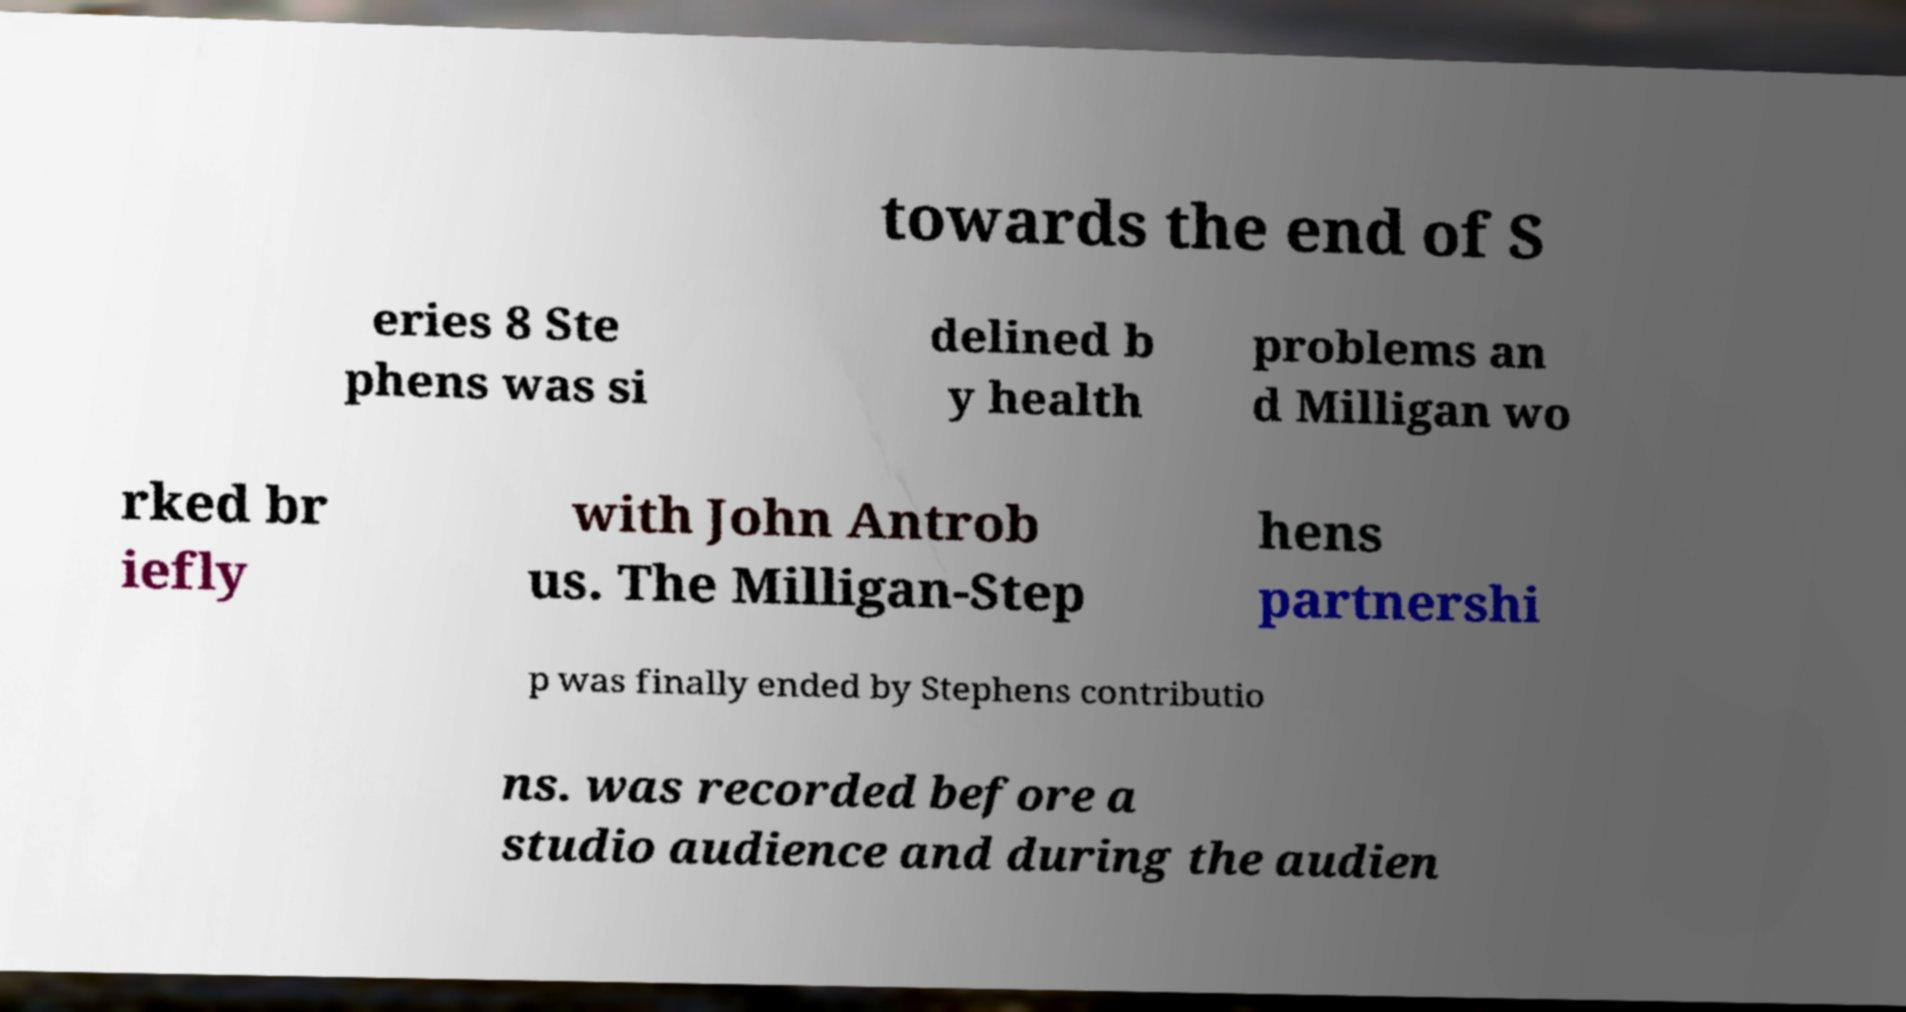Can you accurately transcribe the text from the provided image for me? towards the end of S eries 8 Ste phens was si delined b y health problems an d Milligan wo rked br iefly with John Antrob us. The Milligan-Step hens partnershi p was finally ended by Stephens contributio ns. was recorded before a studio audience and during the audien 